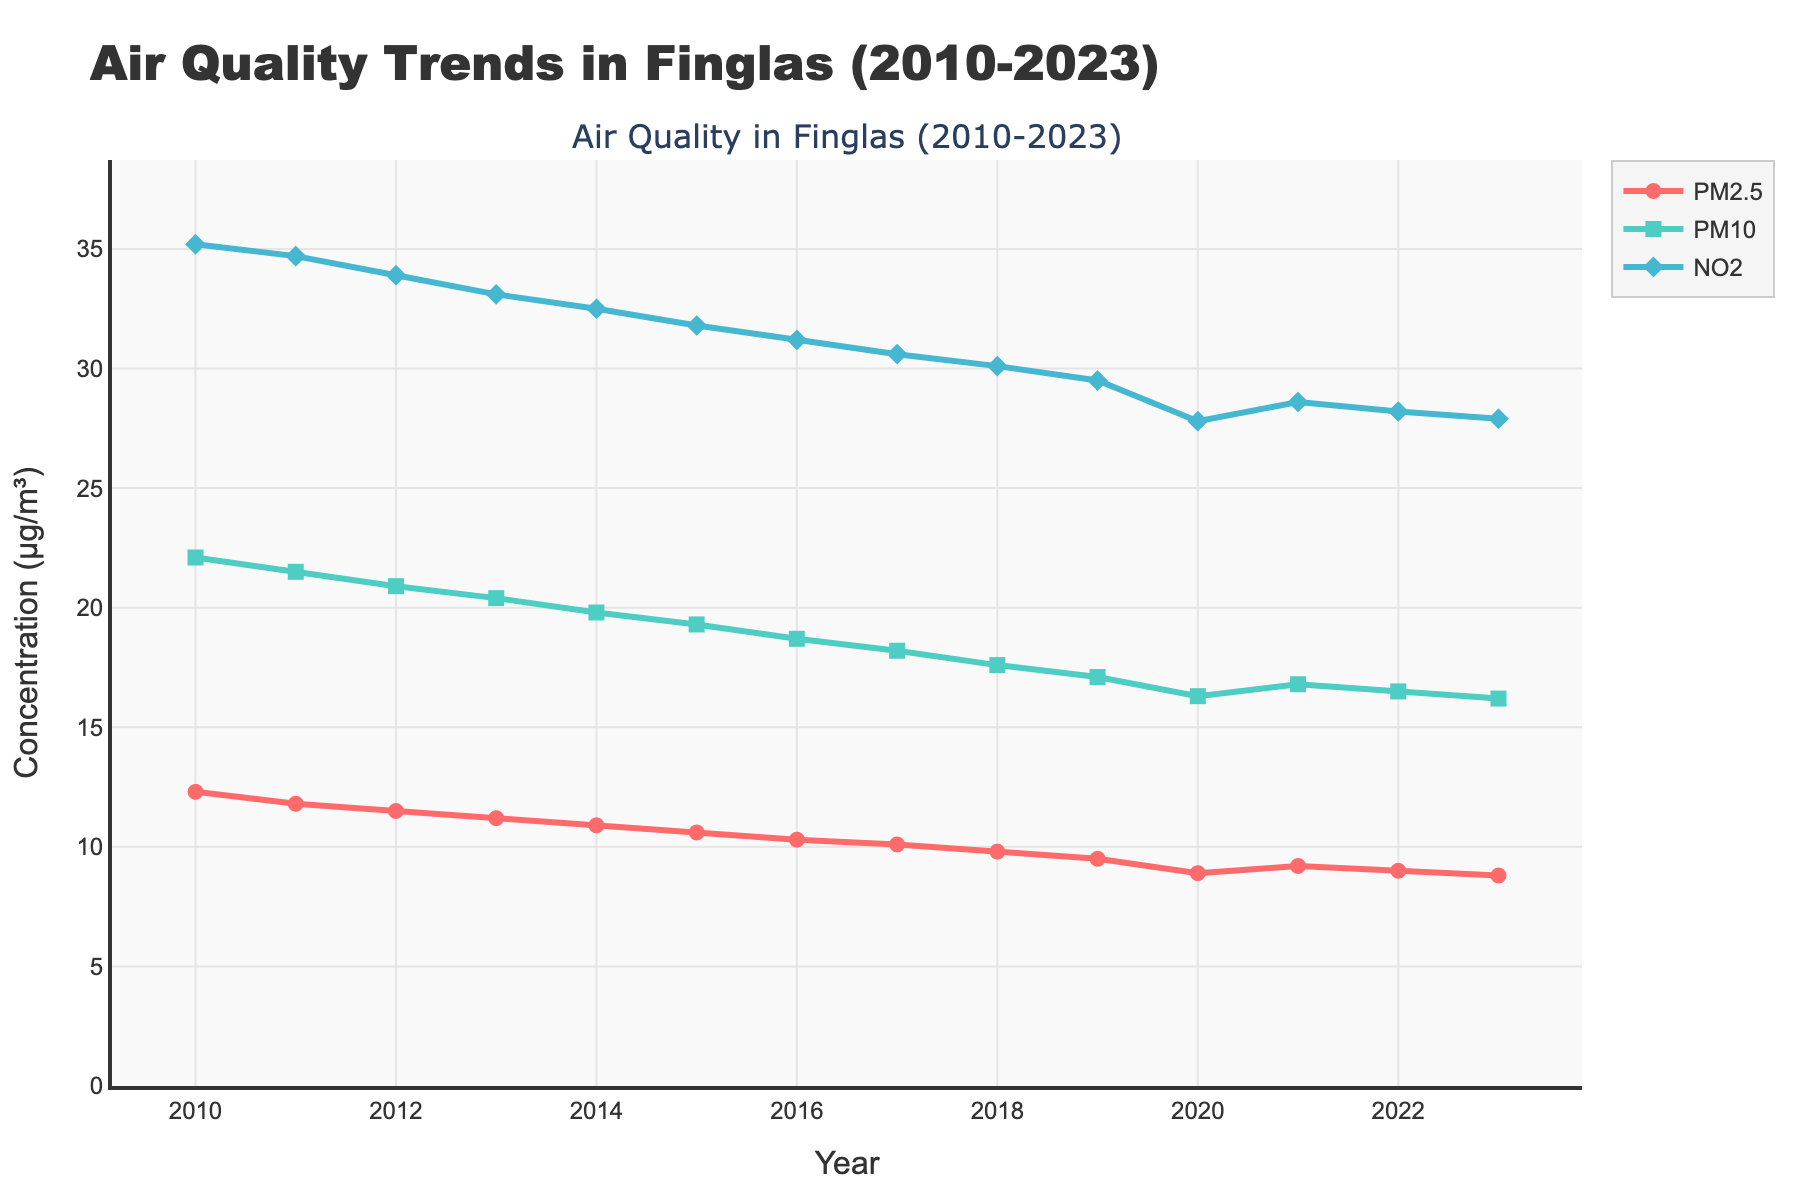What's the general trend of PM2.5 levels from 2010 to 2023? To find the general trend, we look at the line representing PM2.5 from 2010 to 2023. It starts at a higher value in 2010 and gradually decreases until 2023.
Answer: Decreasing How do the levels of PM2.5 in 2011 compare to those in 2021? By examining the values of PM2.5 in 2011 and 2021 on the figure, we see that PM2.5 was higher in 2011 (11.8 μg/m³) compared to 2021 (9.2 μg/m³).
Answer: Lower in 2021 Which year recorded the lowest NO2 level, and what was that level? We check the values for NO2 across all years and see that the lowest value is in 2023 with a concentration of 27.9 μg/m³.
Answer: 2023, 27.9 μg/m³ Compare the rate of decrease of PM10 and NO2 from 2010 to 2020. Which one decreased faster? To determine the rate of decrease, calculate the difference between 2010 and 2020 for both pollutants and compare them. PM10 decreased from 22.1 to 16.3 (5.8 μg/m³), while NO2 decreased from 35.2 to 27.8 (7.4 μg/m³). NO2 decreased faster.
Answer: NO2 What was the average NO2 level between 2010 and 2015? Calculate the average by adding the NO2 levels from 2010 to 2015 and dividing by the number of years: (35.2 + 34.7 + 33.9 + 33.1 + 32.5 + 31.8) / 6 = 201.2 / 6.
Answer: 33.53 μg/m³ Is there a year where all three pollutants (PM2.5, PM10, NO2) either increased or decreased compared to the previous year? By tracking year-to-year changes, 2021 shows a slight increase for all three pollutants compared to 2020: PM2.5 (8.9 to 9.2), PM10 (16.3 to 16.8), NO2 (27.8 to 28.6).
Answer: 2021 In which year did PM10 drop below 20 μg/m³ for the first time? By checking the PM10 values year by year, we see that in 2014, PM10 was 19.8 μg/m³, dropping below 20 μg/m³ for the first time.
Answer: 2014 By what percentage did PM2.5 levels decrease from 2010 to 2023? Calculate the percentage decrease using the formula: [(12.3 - 8.8) / 12.3] * 100 = 28.46%.
Answer: 28.46% What is the difference in PM10 levels between 2012 and 2018? To find the difference, subtract the PM10 value in 2018 from that in 2012: 20.9 - 17.6 = 3.3 μg/m³.
Answer: 3.3 μg/m³ 